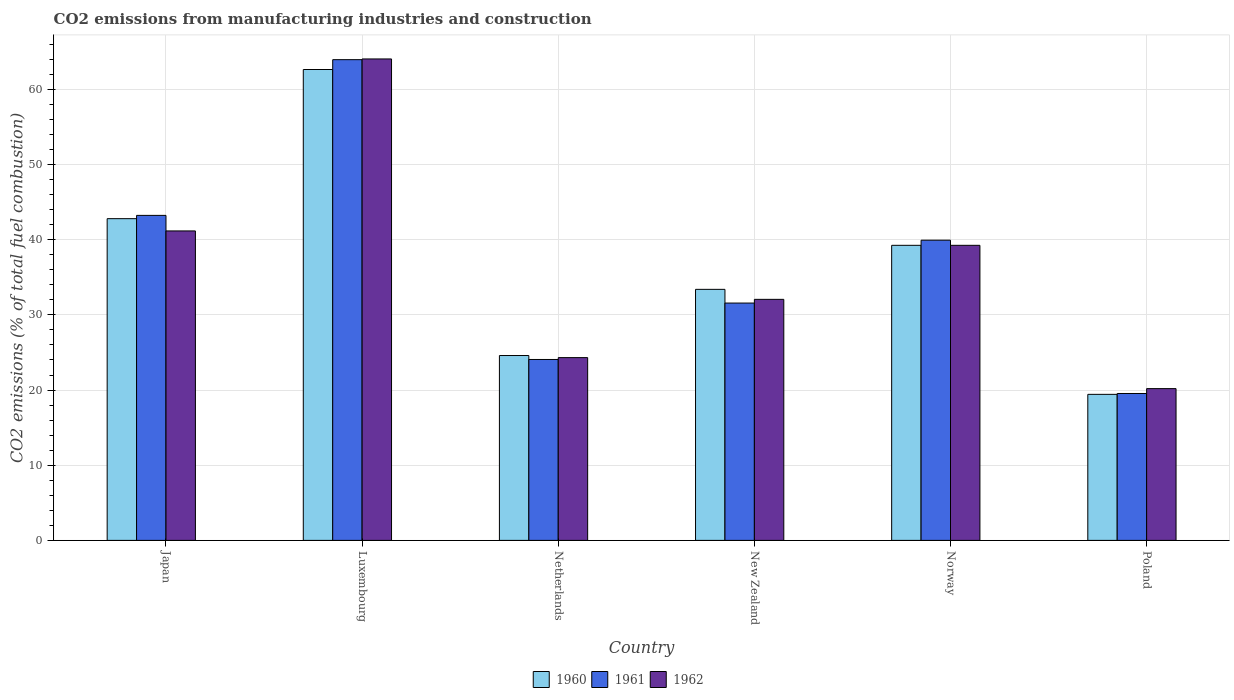How many different coloured bars are there?
Provide a short and direct response. 3. How many groups of bars are there?
Make the answer very short. 6. Are the number of bars on each tick of the X-axis equal?
Provide a short and direct response. Yes. How many bars are there on the 5th tick from the right?
Ensure brevity in your answer.  3. In how many cases, is the number of bars for a given country not equal to the number of legend labels?
Your answer should be compact. 0. What is the amount of CO2 emitted in 1961 in Japan?
Ensure brevity in your answer.  43.24. Across all countries, what is the maximum amount of CO2 emitted in 1960?
Provide a succinct answer. 62.65. Across all countries, what is the minimum amount of CO2 emitted in 1962?
Give a very brief answer. 20.19. In which country was the amount of CO2 emitted in 1962 maximum?
Give a very brief answer. Luxembourg. In which country was the amount of CO2 emitted in 1962 minimum?
Provide a short and direct response. Poland. What is the total amount of CO2 emitted in 1962 in the graph?
Offer a very short reply. 221.05. What is the difference between the amount of CO2 emitted in 1960 in Luxembourg and that in Netherlands?
Keep it short and to the point. 38.05. What is the difference between the amount of CO2 emitted in 1962 in Luxembourg and the amount of CO2 emitted in 1960 in Netherlands?
Give a very brief answer. 39.46. What is the average amount of CO2 emitted in 1961 per country?
Your response must be concise. 37.05. What is the difference between the amount of CO2 emitted of/in 1961 and amount of CO2 emitted of/in 1962 in Japan?
Your response must be concise. 2.07. What is the ratio of the amount of CO2 emitted in 1962 in Luxembourg to that in Poland?
Provide a succinct answer. 3.17. Is the amount of CO2 emitted in 1961 in Netherlands less than that in Norway?
Keep it short and to the point. Yes. What is the difference between the highest and the second highest amount of CO2 emitted in 1962?
Ensure brevity in your answer.  22.88. What is the difference between the highest and the lowest amount of CO2 emitted in 1960?
Your answer should be very brief. 43.22. What does the 3rd bar from the right in Netherlands represents?
Offer a very short reply. 1960. Is it the case that in every country, the sum of the amount of CO2 emitted in 1960 and amount of CO2 emitted in 1961 is greater than the amount of CO2 emitted in 1962?
Provide a short and direct response. Yes. What is the difference between two consecutive major ticks on the Y-axis?
Make the answer very short. 10. Are the values on the major ticks of Y-axis written in scientific E-notation?
Your response must be concise. No. Does the graph contain any zero values?
Offer a very short reply. No. What is the title of the graph?
Ensure brevity in your answer.  CO2 emissions from manufacturing industries and construction. What is the label or title of the Y-axis?
Make the answer very short. CO2 emissions (% of total fuel combustion). What is the CO2 emissions (% of total fuel combustion) of 1960 in Japan?
Offer a terse response. 42.8. What is the CO2 emissions (% of total fuel combustion) of 1961 in Japan?
Provide a succinct answer. 43.24. What is the CO2 emissions (% of total fuel combustion) in 1962 in Japan?
Your response must be concise. 41.17. What is the CO2 emissions (% of total fuel combustion) in 1960 in Luxembourg?
Your response must be concise. 62.65. What is the CO2 emissions (% of total fuel combustion) of 1961 in Luxembourg?
Your response must be concise. 63.95. What is the CO2 emissions (% of total fuel combustion) in 1962 in Luxembourg?
Offer a terse response. 64.05. What is the CO2 emissions (% of total fuel combustion) of 1960 in Netherlands?
Your answer should be very brief. 24.59. What is the CO2 emissions (% of total fuel combustion) in 1961 in Netherlands?
Provide a short and direct response. 24.07. What is the CO2 emissions (% of total fuel combustion) of 1962 in Netherlands?
Make the answer very short. 24.32. What is the CO2 emissions (% of total fuel combustion) of 1960 in New Zealand?
Offer a very short reply. 33.4. What is the CO2 emissions (% of total fuel combustion) in 1961 in New Zealand?
Your answer should be very brief. 31.57. What is the CO2 emissions (% of total fuel combustion) in 1962 in New Zealand?
Provide a succinct answer. 32.07. What is the CO2 emissions (% of total fuel combustion) in 1960 in Norway?
Your answer should be compact. 39.26. What is the CO2 emissions (% of total fuel combustion) of 1961 in Norway?
Ensure brevity in your answer.  39.94. What is the CO2 emissions (% of total fuel combustion) of 1962 in Norway?
Offer a terse response. 39.26. What is the CO2 emissions (% of total fuel combustion) in 1960 in Poland?
Your answer should be very brief. 19.43. What is the CO2 emissions (% of total fuel combustion) of 1961 in Poland?
Your answer should be compact. 19.54. What is the CO2 emissions (% of total fuel combustion) in 1962 in Poland?
Your answer should be compact. 20.19. Across all countries, what is the maximum CO2 emissions (% of total fuel combustion) of 1960?
Make the answer very short. 62.65. Across all countries, what is the maximum CO2 emissions (% of total fuel combustion) of 1961?
Keep it short and to the point. 63.95. Across all countries, what is the maximum CO2 emissions (% of total fuel combustion) in 1962?
Your response must be concise. 64.05. Across all countries, what is the minimum CO2 emissions (% of total fuel combustion) of 1960?
Ensure brevity in your answer.  19.43. Across all countries, what is the minimum CO2 emissions (% of total fuel combustion) in 1961?
Offer a very short reply. 19.54. Across all countries, what is the minimum CO2 emissions (% of total fuel combustion) in 1962?
Provide a succinct answer. 20.19. What is the total CO2 emissions (% of total fuel combustion) in 1960 in the graph?
Your answer should be compact. 222.12. What is the total CO2 emissions (% of total fuel combustion) in 1961 in the graph?
Offer a terse response. 222.32. What is the total CO2 emissions (% of total fuel combustion) of 1962 in the graph?
Your answer should be compact. 221.05. What is the difference between the CO2 emissions (% of total fuel combustion) in 1960 in Japan and that in Luxembourg?
Ensure brevity in your answer.  -19.84. What is the difference between the CO2 emissions (% of total fuel combustion) of 1961 in Japan and that in Luxembourg?
Your answer should be very brief. -20.72. What is the difference between the CO2 emissions (% of total fuel combustion) of 1962 in Japan and that in Luxembourg?
Provide a succinct answer. -22.88. What is the difference between the CO2 emissions (% of total fuel combustion) in 1960 in Japan and that in Netherlands?
Your answer should be very brief. 18.21. What is the difference between the CO2 emissions (% of total fuel combustion) in 1961 in Japan and that in Netherlands?
Give a very brief answer. 19.17. What is the difference between the CO2 emissions (% of total fuel combustion) of 1962 in Japan and that in Netherlands?
Ensure brevity in your answer.  16.85. What is the difference between the CO2 emissions (% of total fuel combustion) of 1960 in Japan and that in New Zealand?
Keep it short and to the point. 9.4. What is the difference between the CO2 emissions (% of total fuel combustion) in 1961 in Japan and that in New Zealand?
Keep it short and to the point. 11.66. What is the difference between the CO2 emissions (% of total fuel combustion) of 1962 in Japan and that in New Zealand?
Give a very brief answer. 9.1. What is the difference between the CO2 emissions (% of total fuel combustion) of 1960 in Japan and that in Norway?
Ensure brevity in your answer.  3.55. What is the difference between the CO2 emissions (% of total fuel combustion) in 1961 in Japan and that in Norway?
Offer a very short reply. 3.3. What is the difference between the CO2 emissions (% of total fuel combustion) in 1962 in Japan and that in Norway?
Your answer should be very brief. 1.91. What is the difference between the CO2 emissions (% of total fuel combustion) in 1960 in Japan and that in Poland?
Offer a very short reply. 23.37. What is the difference between the CO2 emissions (% of total fuel combustion) of 1961 in Japan and that in Poland?
Make the answer very short. 23.69. What is the difference between the CO2 emissions (% of total fuel combustion) of 1962 in Japan and that in Poland?
Keep it short and to the point. 20.98. What is the difference between the CO2 emissions (% of total fuel combustion) of 1960 in Luxembourg and that in Netherlands?
Give a very brief answer. 38.05. What is the difference between the CO2 emissions (% of total fuel combustion) of 1961 in Luxembourg and that in Netherlands?
Provide a succinct answer. 39.88. What is the difference between the CO2 emissions (% of total fuel combustion) of 1962 in Luxembourg and that in Netherlands?
Make the answer very short. 39.73. What is the difference between the CO2 emissions (% of total fuel combustion) in 1960 in Luxembourg and that in New Zealand?
Provide a succinct answer. 29.25. What is the difference between the CO2 emissions (% of total fuel combustion) in 1961 in Luxembourg and that in New Zealand?
Offer a very short reply. 32.38. What is the difference between the CO2 emissions (% of total fuel combustion) in 1962 in Luxembourg and that in New Zealand?
Make the answer very short. 31.98. What is the difference between the CO2 emissions (% of total fuel combustion) of 1960 in Luxembourg and that in Norway?
Make the answer very short. 23.39. What is the difference between the CO2 emissions (% of total fuel combustion) in 1961 in Luxembourg and that in Norway?
Your answer should be very brief. 24.02. What is the difference between the CO2 emissions (% of total fuel combustion) of 1962 in Luxembourg and that in Norway?
Provide a short and direct response. 24.79. What is the difference between the CO2 emissions (% of total fuel combustion) in 1960 in Luxembourg and that in Poland?
Provide a short and direct response. 43.22. What is the difference between the CO2 emissions (% of total fuel combustion) in 1961 in Luxembourg and that in Poland?
Ensure brevity in your answer.  44.41. What is the difference between the CO2 emissions (% of total fuel combustion) of 1962 in Luxembourg and that in Poland?
Your answer should be very brief. 43.86. What is the difference between the CO2 emissions (% of total fuel combustion) in 1960 in Netherlands and that in New Zealand?
Offer a terse response. -8.8. What is the difference between the CO2 emissions (% of total fuel combustion) of 1961 in Netherlands and that in New Zealand?
Ensure brevity in your answer.  -7.5. What is the difference between the CO2 emissions (% of total fuel combustion) in 1962 in Netherlands and that in New Zealand?
Your response must be concise. -7.75. What is the difference between the CO2 emissions (% of total fuel combustion) of 1960 in Netherlands and that in Norway?
Provide a short and direct response. -14.66. What is the difference between the CO2 emissions (% of total fuel combustion) in 1961 in Netherlands and that in Norway?
Your response must be concise. -15.87. What is the difference between the CO2 emissions (% of total fuel combustion) of 1962 in Netherlands and that in Norway?
Provide a short and direct response. -14.94. What is the difference between the CO2 emissions (% of total fuel combustion) in 1960 in Netherlands and that in Poland?
Ensure brevity in your answer.  5.17. What is the difference between the CO2 emissions (% of total fuel combustion) of 1961 in Netherlands and that in Poland?
Your answer should be compact. 4.53. What is the difference between the CO2 emissions (% of total fuel combustion) of 1962 in Netherlands and that in Poland?
Provide a short and direct response. 4.13. What is the difference between the CO2 emissions (% of total fuel combustion) in 1960 in New Zealand and that in Norway?
Give a very brief answer. -5.86. What is the difference between the CO2 emissions (% of total fuel combustion) in 1961 in New Zealand and that in Norway?
Make the answer very short. -8.36. What is the difference between the CO2 emissions (% of total fuel combustion) in 1962 in New Zealand and that in Norway?
Keep it short and to the point. -7.19. What is the difference between the CO2 emissions (% of total fuel combustion) in 1960 in New Zealand and that in Poland?
Give a very brief answer. 13.97. What is the difference between the CO2 emissions (% of total fuel combustion) in 1961 in New Zealand and that in Poland?
Give a very brief answer. 12.03. What is the difference between the CO2 emissions (% of total fuel combustion) in 1962 in New Zealand and that in Poland?
Give a very brief answer. 11.88. What is the difference between the CO2 emissions (% of total fuel combustion) of 1960 in Norway and that in Poland?
Your answer should be compact. 19.83. What is the difference between the CO2 emissions (% of total fuel combustion) of 1961 in Norway and that in Poland?
Your answer should be compact. 20.39. What is the difference between the CO2 emissions (% of total fuel combustion) in 1962 in Norway and that in Poland?
Provide a short and direct response. 19.06. What is the difference between the CO2 emissions (% of total fuel combustion) in 1960 in Japan and the CO2 emissions (% of total fuel combustion) in 1961 in Luxembourg?
Give a very brief answer. -21.15. What is the difference between the CO2 emissions (% of total fuel combustion) of 1960 in Japan and the CO2 emissions (% of total fuel combustion) of 1962 in Luxembourg?
Keep it short and to the point. -21.25. What is the difference between the CO2 emissions (% of total fuel combustion) of 1961 in Japan and the CO2 emissions (% of total fuel combustion) of 1962 in Luxembourg?
Offer a terse response. -20.81. What is the difference between the CO2 emissions (% of total fuel combustion) of 1960 in Japan and the CO2 emissions (% of total fuel combustion) of 1961 in Netherlands?
Your answer should be very brief. 18.73. What is the difference between the CO2 emissions (% of total fuel combustion) of 1960 in Japan and the CO2 emissions (% of total fuel combustion) of 1962 in Netherlands?
Give a very brief answer. 18.49. What is the difference between the CO2 emissions (% of total fuel combustion) in 1961 in Japan and the CO2 emissions (% of total fuel combustion) in 1962 in Netherlands?
Make the answer very short. 18.92. What is the difference between the CO2 emissions (% of total fuel combustion) in 1960 in Japan and the CO2 emissions (% of total fuel combustion) in 1961 in New Zealand?
Your response must be concise. 11.23. What is the difference between the CO2 emissions (% of total fuel combustion) in 1960 in Japan and the CO2 emissions (% of total fuel combustion) in 1962 in New Zealand?
Provide a short and direct response. 10.73. What is the difference between the CO2 emissions (% of total fuel combustion) of 1961 in Japan and the CO2 emissions (% of total fuel combustion) of 1962 in New Zealand?
Give a very brief answer. 11.17. What is the difference between the CO2 emissions (% of total fuel combustion) in 1960 in Japan and the CO2 emissions (% of total fuel combustion) in 1961 in Norway?
Provide a succinct answer. 2.86. What is the difference between the CO2 emissions (% of total fuel combustion) of 1960 in Japan and the CO2 emissions (% of total fuel combustion) of 1962 in Norway?
Offer a terse response. 3.55. What is the difference between the CO2 emissions (% of total fuel combustion) of 1961 in Japan and the CO2 emissions (% of total fuel combustion) of 1962 in Norway?
Offer a terse response. 3.98. What is the difference between the CO2 emissions (% of total fuel combustion) of 1960 in Japan and the CO2 emissions (% of total fuel combustion) of 1961 in Poland?
Offer a terse response. 23.26. What is the difference between the CO2 emissions (% of total fuel combustion) in 1960 in Japan and the CO2 emissions (% of total fuel combustion) in 1962 in Poland?
Offer a very short reply. 22.61. What is the difference between the CO2 emissions (% of total fuel combustion) in 1961 in Japan and the CO2 emissions (% of total fuel combustion) in 1962 in Poland?
Make the answer very short. 23.05. What is the difference between the CO2 emissions (% of total fuel combustion) in 1960 in Luxembourg and the CO2 emissions (% of total fuel combustion) in 1961 in Netherlands?
Provide a succinct answer. 38.58. What is the difference between the CO2 emissions (% of total fuel combustion) in 1960 in Luxembourg and the CO2 emissions (% of total fuel combustion) in 1962 in Netherlands?
Ensure brevity in your answer.  38.33. What is the difference between the CO2 emissions (% of total fuel combustion) in 1961 in Luxembourg and the CO2 emissions (% of total fuel combustion) in 1962 in Netherlands?
Your answer should be very brief. 39.64. What is the difference between the CO2 emissions (% of total fuel combustion) of 1960 in Luxembourg and the CO2 emissions (% of total fuel combustion) of 1961 in New Zealand?
Give a very brief answer. 31.07. What is the difference between the CO2 emissions (% of total fuel combustion) in 1960 in Luxembourg and the CO2 emissions (% of total fuel combustion) in 1962 in New Zealand?
Your answer should be compact. 30.58. What is the difference between the CO2 emissions (% of total fuel combustion) in 1961 in Luxembourg and the CO2 emissions (% of total fuel combustion) in 1962 in New Zealand?
Your answer should be compact. 31.89. What is the difference between the CO2 emissions (% of total fuel combustion) in 1960 in Luxembourg and the CO2 emissions (% of total fuel combustion) in 1961 in Norway?
Provide a succinct answer. 22.71. What is the difference between the CO2 emissions (% of total fuel combustion) of 1960 in Luxembourg and the CO2 emissions (% of total fuel combustion) of 1962 in Norway?
Make the answer very short. 23.39. What is the difference between the CO2 emissions (% of total fuel combustion) in 1961 in Luxembourg and the CO2 emissions (% of total fuel combustion) in 1962 in Norway?
Your answer should be compact. 24.7. What is the difference between the CO2 emissions (% of total fuel combustion) in 1960 in Luxembourg and the CO2 emissions (% of total fuel combustion) in 1961 in Poland?
Provide a short and direct response. 43.1. What is the difference between the CO2 emissions (% of total fuel combustion) in 1960 in Luxembourg and the CO2 emissions (% of total fuel combustion) in 1962 in Poland?
Ensure brevity in your answer.  42.45. What is the difference between the CO2 emissions (% of total fuel combustion) of 1961 in Luxembourg and the CO2 emissions (% of total fuel combustion) of 1962 in Poland?
Your response must be concise. 43.76. What is the difference between the CO2 emissions (% of total fuel combustion) of 1960 in Netherlands and the CO2 emissions (% of total fuel combustion) of 1961 in New Zealand?
Provide a succinct answer. -6.98. What is the difference between the CO2 emissions (% of total fuel combustion) in 1960 in Netherlands and the CO2 emissions (% of total fuel combustion) in 1962 in New Zealand?
Your answer should be very brief. -7.47. What is the difference between the CO2 emissions (% of total fuel combustion) of 1961 in Netherlands and the CO2 emissions (% of total fuel combustion) of 1962 in New Zealand?
Give a very brief answer. -8. What is the difference between the CO2 emissions (% of total fuel combustion) of 1960 in Netherlands and the CO2 emissions (% of total fuel combustion) of 1961 in Norway?
Give a very brief answer. -15.34. What is the difference between the CO2 emissions (% of total fuel combustion) in 1960 in Netherlands and the CO2 emissions (% of total fuel combustion) in 1962 in Norway?
Give a very brief answer. -14.66. What is the difference between the CO2 emissions (% of total fuel combustion) of 1961 in Netherlands and the CO2 emissions (% of total fuel combustion) of 1962 in Norway?
Give a very brief answer. -15.19. What is the difference between the CO2 emissions (% of total fuel combustion) in 1960 in Netherlands and the CO2 emissions (% of total fuel combustion) in 1961 in Poland?
Keep it short and to the point. 5.05. What is the difference between the CO2 emissions (% of total fuel combustion) of 1960 in Netherlands and the CO2 emissions (% of total fuel combustion) of 1962 in Poland?
Make the answer very short. 4.4. What is the difference between the CO2 emissions (% of total fuel combustion) in 1961 in Netherlands and the CO2 emissions (% of total fuel combustion) in 1962 in Poland?
Provide a succinct answer. 3.88. What is the difference between the CO2 emissions (% of total fuel combustion) in 1960 in New Zealand and the CO2 emissions (% of total fuel combustion) in 1961 in Norway?
Your answer should be very brief. -6.54. What is the difference between the CO2 emissions (% of total fuel combustion) of 1960 in New Zealand and the CO2 emissions (% of total fuel combustion) of 1962 in Norway?
Your answer should be compact. -5.86. What is the difference between the CO2 emissions (% of total fuel combustion) in 1961 in New Zealand and the CO2 emissions (% of total fuel combustion) in 1962 in Norway?
Make the answer very short. -7.68. What is the difference between the CO2 emissions (% of total fuel combustion) of 1960 in New Zealand and the CO2 emissions (% of total fuel combustion) of 1961 in Poland?
Your answer should be compact. 13.85. What is the difference between the CO2 emissions (% of total fuel combustion) in 1960 in New Zealand and the CO2 emissions (% of total fuel combustion) in 1962 in Poland?
Your answer should be very brief. 13.21. What is the difference between the CO2 emissions (% of total fuel combustion) of 1961 in New Zealand and the CO2 emissions (% of total fuel combustion) of 1962 in Poland?
Provide a short and direct response. 11.38. What is the difference between the CO2 emissions (% of total fuel combustion) of 1960 in Norway and the CO2 emissions (% of total fuel combustion) of 1961 in Poland?
Ensure brevity in your answer.  19.71. What is the difference between the CO2 emissions (% of total fuel combustion) of 1960 in Norway and the CO2 emissions (% of total fuel combustion) of 1962 in Poland?
Ensure brevity in your answer.  19.06. What is the difference between the CO2 emissions (% of total fuel combustion) in 1961 in Norway and the CO2 emissions (% of total fuel combustion) in 1962 in Poland?
Your answer should be compact. 19.75. What is the average CO2 emissions (% of total fuel combustion) of 1960 per country?
Provide a succinct answer. 37.02. What is the average CO2 emissions (% of total fuel combustion) in 1961 per country?
Your response must be concise. 37.05. What is the average CO2 emissions (% of total fuel combustion) of 1962 per country?
Provide a short and direct response. 36.84. What is the difference between the CO2 emissions (% of total fuel combustion) of 1960 and CO2 emissions (% of total fuel combustion) of 1961 in Japan?
Offer a terse response. -0.44. What is the difference between the CO2 emissions (% of total fuel combustion) in 1960 and CO2 emissions (% of total fuel combustion) in 1962 in Japan?
Make the answer very short. 1.63. What is the difference between the CO2 emissions (% of total fuel combustion) in 1961 and CO2 emissions (% of total fuel combustion) in 1962 in Japan?
Your answer should be very brief. 2.07. What is the difference between the CO2 emissions (% of total fuel combustion) in 1960 and CO2 emissions (% of total fuel combustion) in 1961 in Luxembourg?
Your answer should be compact. -1.31. What is the difference between the CO2 emissions (% of total fuel combustion) in 1960 and CO2 emissions (% of total fuel combustion) in 1962 in Luxembourg?
Provide a succinct answer. -1.4. What is the difference between the CO2 emissions (% of total fuel combustion) in 1961 and CO2 emissions (% of total fuel combustion) in 1962 in Luxembourg?
Give a very brief answer. -0.1. What is the difference between the CO2 emissions (% of total fuel combustion) of 1960 and CO2 emissions (% of total fuel combustion) of 1961 in Netherlands?
Offer a terse response. 0.52. What is the difference between the CO2 emissions (% of total fuel combustion) of 1960 and CO2 emissions (% of total fuel combustion) of 1962 in Netherlands?
Make the answer very short. 0.28. What is the difference between the CO2 emissions (% of total fuel combustion) in 1961 and CO2 emissions (% of total fuel combustion) in 1962 in Netherlands?
Your answer should be very brief. -0.25. What is the difference between the CO2 emissions (% of total fuel combustion) of 1960 and CO2 emissions (% of total fuel combustion) of 1961 in New Zealand?
Offer a terse response. 1.82. What is the difference between the CO2 emissions (% of total fuel combustion) in 1960 and CO2 emissions (% of total fuel combustion) in 1962 in New Zealand?
Keep it short and to the point. 1.33. What is the difference between the CO2 emissions (% of total fuel combustion) in 1961 and CO2 emissions (% of total fuel combustion) in 1962 in New Zealand?
Give a very brief answer. -0.49. What is the difference between the CO2 emissions (% of total fuel combustion) of 1960 and CO2 emissions (% of total fuel combustion) of 1961 in Norway?
Provide a succinct answer. -0.68. What is the difference between the CO2 emissions (% of total fuel combustion) in 1961 and CO2 emissions (% of total fuel combustion) in 1962 in Norway?
Keep it short and to the point. 0.68. What is the difference between the CO2 emissions (% of total fuel combustion) in 1960 and CO2 emissions (% of total fuel combustion) in 1961 in Poland?
Offer a very short reply. -0.11. What is the difference between the CO2 emissions (% of total fuel combustion) in 1960 and CO2 emissions (% of total fuel combustion) in 1962 in Poland?
Provide a short and direct response. -0.76. What is the difference between the CO2 emissions (% of total fuel combustion) in 1961 and CO2 emissions (% of total fuel combustion) in 1962 in Poland?
Give a very brief answer. -0.65. What is the ratio of the CO2 emissions (% of total fuel combustion) in 1960 in Japan to that in Luxembourg?
Offer a terse response. 0.68. What is the ratio of the CO2 emissions (% of total fuel combustion) of 1961 in Japan to that in Luxembourg?
Provide a succinct answer. 0.68. What is the ratio of the CO2 emissions (% of total fuel combustion) in 1962 in Japan to that in Luxembourg?
Give a very brief answer. 0.64. What is the ratio of the CO2 emissions (% of total fuel combustion) in 1960 in Japan to that in Netherlands?
Ensure brevity in your answer.  1.74. What is the ratio of the CO2 emissions (% of total fuel combustion) of 1961 in Japan to that in Netherlands?
Give a very brief answer. 1.8. What is the ratio of the CO2 emissions (% of total fuel combustion) of 1962 in Japan to that in Netherlands?
Keep it short and to the point. 1.69. What is the ratio of the CO2 emissions (% of total fuel combustion) of 1960 in Japan to that in New Zealand?
Give a very brief answer. 1.28. What is the ratio of the CO2 emissions (% of total fuel combustion) in 1961 in Japan to that in New Zealand?
Your answer should be compact. 1.37. What is the ratio of the CO2 emissions (% of total fuel combustion) of 1962 in Japan to that in New Zealand?
Make the answer very short. 1.28. What is the ratio of the CO2 emissions (% of total fuel combustion) of 1960 in Japan to that in Norway?
Provide a succinct answer. 1.09. What is the ratio of the CO2 emissions (% of total fuel combustion) of 1961 in Japan to that in Norway?
Make the answer very short. 1.08. What is the ratio of the CO2 emissions (% of total fuel combustion) of 1962 in Japan to that in Norway?
Ensure brevity in your answer.  1.05. What is the ratio of the CO2 emissions (% of total fuel combustion) in 1960 in Japan to that in Poland?
Give a very brief answer. 2.2. What is the ratio of the CO2 emissions (% of total fuel combustion) in 1961 in Japan to that in Poland?
Your answer should be very brief. 2.21. What is the ratio of the CO2 emissions (% of total fuel combustion) in 1962 in Japan to that in Poland?
Offer a very short reply. 2.04. What is the ratio of the CO2 emissions (% of total fuel combustion) in 1960 in Luxembourg to that in Netherlands?
Provide a short and direct response. 2.55. What is the ratio of the CO2 emissions (% of total fuel combustion) of 1961 in Luxembourg to that in Netherlands?
Your answer should be compact. 2.66. What is the ratio of the CO2 emissions (% of total fuel combustion) of 1962 in Luxembourg to that in Netherlands?
Make the answer very short. 2.63. What is the ratio of the CO2 emissions (% of total fuel combustion) in 1960 in Luxembourg to that in New Zealand?
Offer a very short reply. 1.88. What is the ratio of the CO2 emissions (% of total fuel combustion) in 1961 in Luxembourg to that in New Zealand?
Provide a succinct answer. 2.03. What is the ratio of the CO2 emissions (% of total fuel combustion) of 1962 in Luxembourg to that in New Zealand?
Your response must be concise. 2. What is the ratio of the CO2 emissions (% of total fuel combustion) of 1960 in Luxembourg to that in Norway?
Offer a very short reply. 1.6. What is the ratio of the CO2 emissions (% of total fuel combustion) of 1961 in Luxembourg to that in Norway?
Offer a terse response. 1.6. What is the ratio of the CO2 emissions (% of total fuel combustion) of 1962 in Luxembourg to that in Norway?
Provide a succinct answer. 1.63. What is the ratio of the CO2 emissions (% of total fuel combustion) of 1960 in Luxembourg to that in Poland?
Provide a succinct answer. 3.22. What is the ratio of the CO2 emissions (% of total fuel combustion) of 1961 in Luxembourg to that in Poland?
Keep it short and to the point. 3.27. What is the ratio of the CO2 emissions (% of total fuel combustion) in 1962 in Luxembourg to that in Poland?
Your answer should be very brief. 3.17. What is the ratio of the CO2 emissions (% of total fuel combustion) in 1960 in Netherlands to that in New Zealand?
Offer a very short reply. 0.74. What is the ratio of the CO2 emissions (% of total fuel combustion) in 1961 in Netherlands to that in New Zealand?
Offer a very short reply. 0.76. What is the ratio of the CO2 emissions (% of total fuel combustion) of 1962 in Netherlands to that in New Zealand?
Offer a very short reply. 0.76. What is the ratio of the CO2 emissions (% of total fuel combustion) of 1960 in Netherlands to that in Norway?
Keep it short and to the point. 0.63. What is the ratio of the CO2 emissions (% of total fuel combustion) of 1961 in Netherlands to that in Norway?
Keep it short and to the point. 0.6. What is the ratio of the CO2 emissions (% of total fuel combustion) of 1962 in Netherlands to that in Norway?
Provide a short and direct response. 0.62. What is the ratio of the CO2 emissions (% of total fuel combustion) in 1960 in Netherlands to that in Poland?
Give a very brief answer. 1.27. What is the ratio of the CO2 emissions (% of total fuel combustion) of 1961 in Netherlands to that in Poland?
Make the answer very short. 1.23. What is the ratio of the CO2 emissions (% of total fuel combustion) in 1962 in Netherlands to that in Poland?
Give a very brief answer. 1.2. What is the ratio of the CO2 emissions (% of total fuel combustion) in 1960 in New Zealand to that in Norway?
Provide a short and direct response. 0.85. What is the ratio of the CO2 emissions (% of total fuel combustion) of 1961 in New Zealand to that in Norway?
Keep it short and to the point. 0.79. What is the ratio of the CO2 emissions (% of total fuel combustion) in 1962 in New Zealand to that in Norway?
Your answer should be very brief. 0.82. What is the ratio of the CO2 emissions (% of total fuel combustion) of 1960 in New Zealand to that in Poland?
Keep it short and to the point. 1.72. What is the ratio of the CO2 emissions (% of total fuel combustion) of 1961 in New Zealand to that in Poland?
Give a very brief answer. 1.62. What is the ratio of the CO2 emissions (% of total fuel combustion) of 1962 in New Zealand to that in Poland?
Offer a terse response. 1.59. What is the ratio of the CO2 emissions (% of total fuel combustion) in 1960 in Norway to that in Poland?
Provide a succinct answer. 2.02. What is the ratio of the CO2 emissions (% of total fuel combustion) of 1961 in Norway to that in Poland?
Your answer should be very brief. 2.04. What is the ratio of the CO2 emissions (% of total fuel combustion) of 1962 in Norway to that in Poland?
Ensure brevity in your answer.  1.94. What is the difference between the highest and the second highest CO2 emissions (% of total fuel combustion) in 1960?
Provide a succinct answer. 19.84. What is the difference between the highest and the second highest CO2 emissions (% of total fuel combustion) of 1961?
Your response must be concise. 20.72. What is the difference between the highest and the second highest CO2 emissions (% of total fuel combustion) in 1962?
Make the answer very short. 22.88. What is the difference between the highest and the lowest CO2 emissions (% of total fuel combustion) in 1960?
Ensure brevity in your answer.  43.22. What is the difference between the highest and the lowest CO2 emissions (% of total fuel combustion) of 1961?
Offer a very short reply. 44.41. What is the difference between the highest and the lowest CO2 emissions (% of total fuel combustion) in 1962?
Your answer should be very brief. 43.86. 